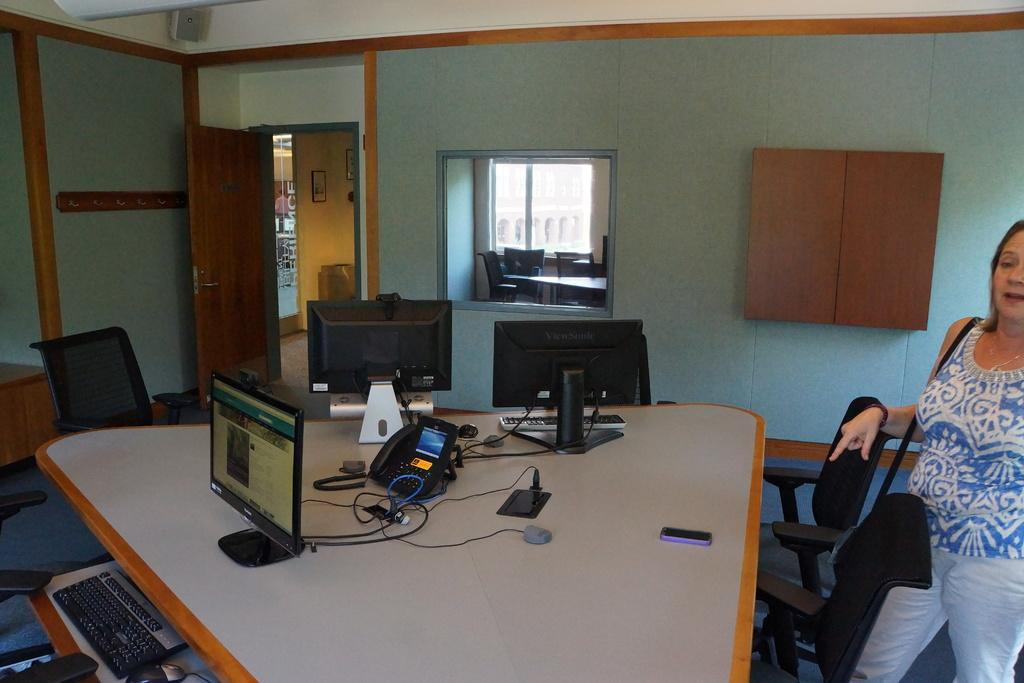What is the main subject in the image? There is a woman standing in the image. What type of furniture can be seen in the image? There are many chairs and a table in the image. What objects are on the table? There are three systems on the table, one of which is a telephone. Is there any source of natural light in the image? Yes, there is a window in the image. Can you see any frogs jumping in the stream in the image? There is no stream or frogs present in the image. 